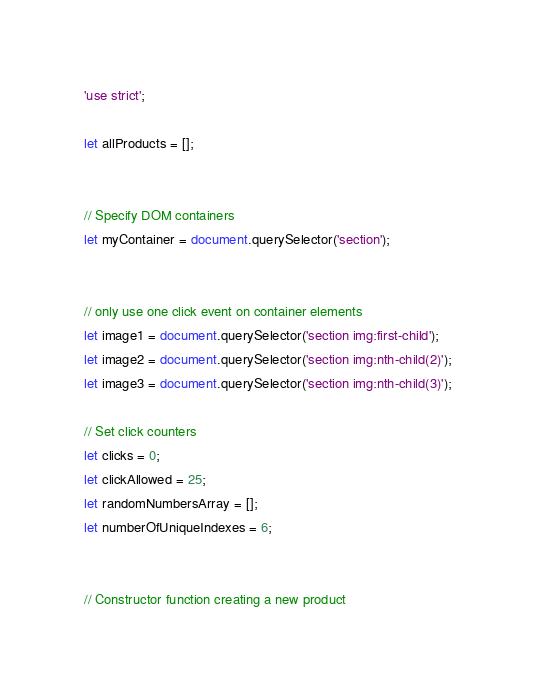<code> <loc_0><loc_0><loc_500><loc_500><_JavaScript_>'use strict';

let allProducts = [];


// Specify DOM containers
let myContainer = document.querySelector('section');


// only use one click event on container elements
let image1 = document.querySelector('section img:first-child');
let image2 = document.querySelector('section img:nth-child(2)');
let image3 = document.querySelector('section img:nth-child(3)');

// Set click counters
let clicks = 0;
let clickAllowed = 25;
let randomNumbersArray = [];
let numberOfUniqueIndexes = 6;


// Constructor function creating a new product</code> 